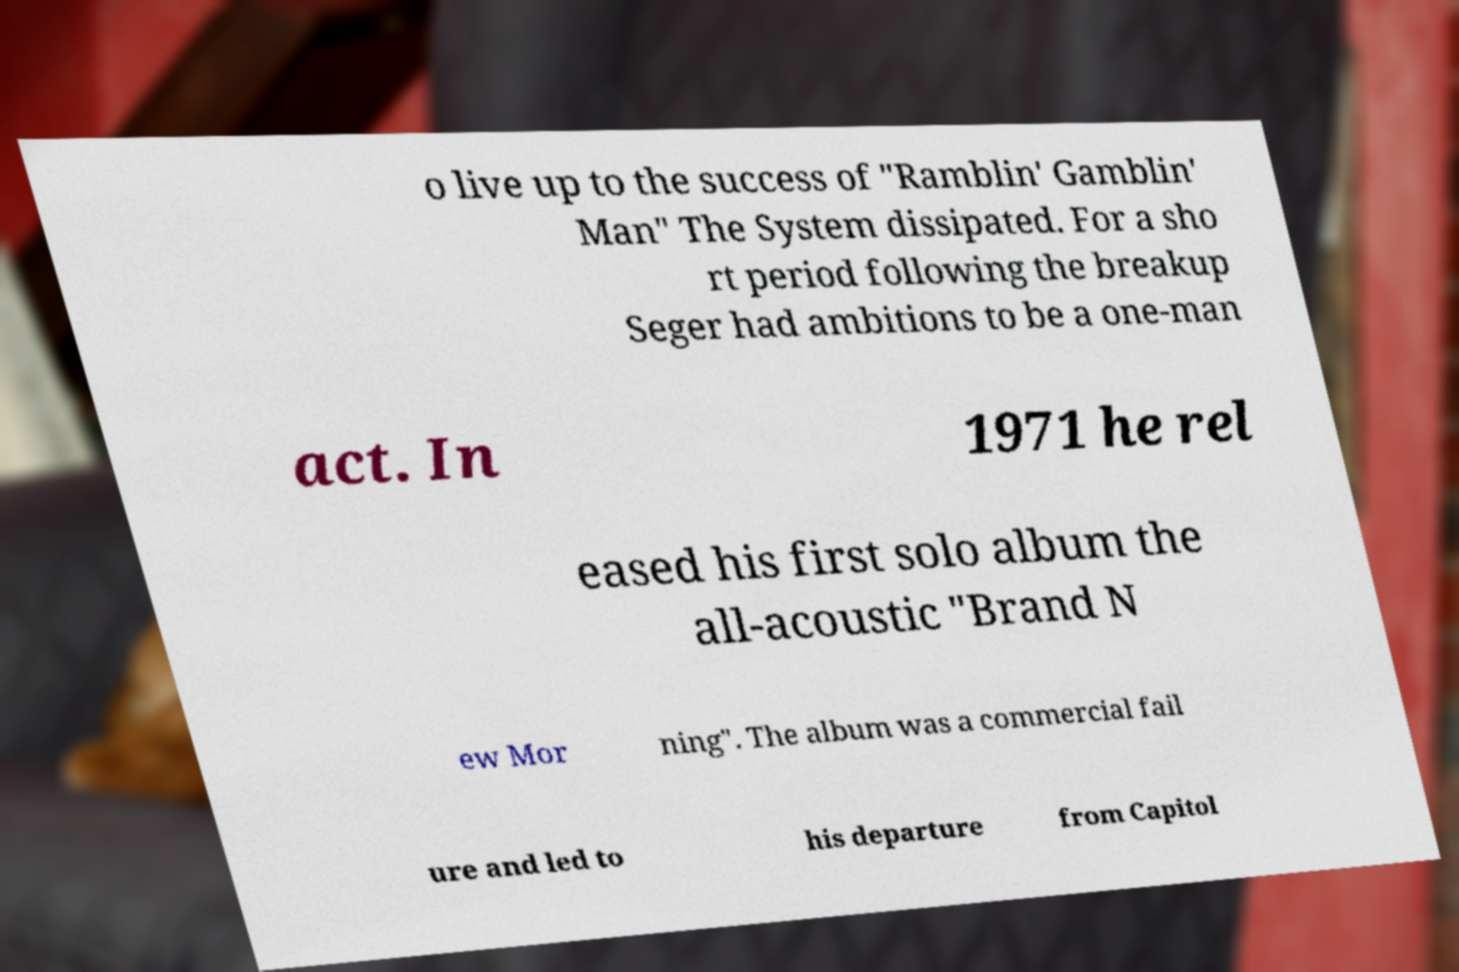Can you read and provide the text displayed in the image?This photo seems to have some interesting text. Can you extract and type it out for me? o live up to the success of "Ramblin' Gamblin' Man" The System dissipated. For a sho rt period following the breakup Seger had ambitions to be a one-man act. In 1971 he rel eased his first solo album the all-acoustic "Brand N ew Mor ning". The album was a commercial fail ure and led to his departure from Capitol 